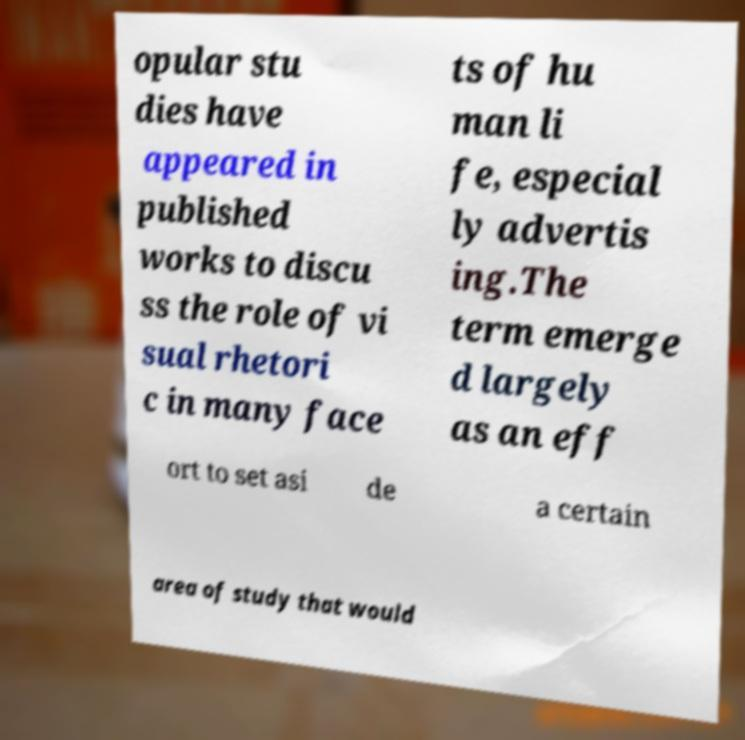Please identify and transcribe the text found in this image. opular stu dies have appeared in published works to discu ss the role of vi sual rhetori c in many face ts of hu man li fe, especial ly advertis ing.The term emerge d largely as an eff ort to set asi de a certain area of study that would 